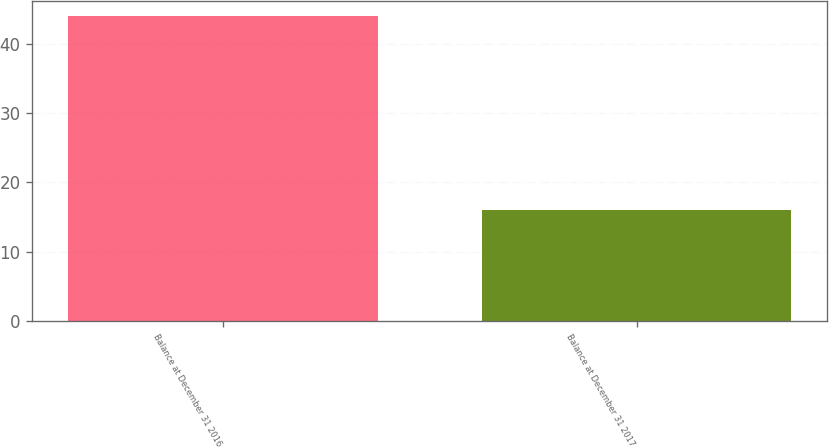Convert chart to OTSL. <chart><loc_0><loc_0><loc_500><loc_500><bar_chart><fcel>Balance at December 31 2016<fcel>Balance at December 31 2017<nl><fcel>44<fcel>16<nl></chart> 